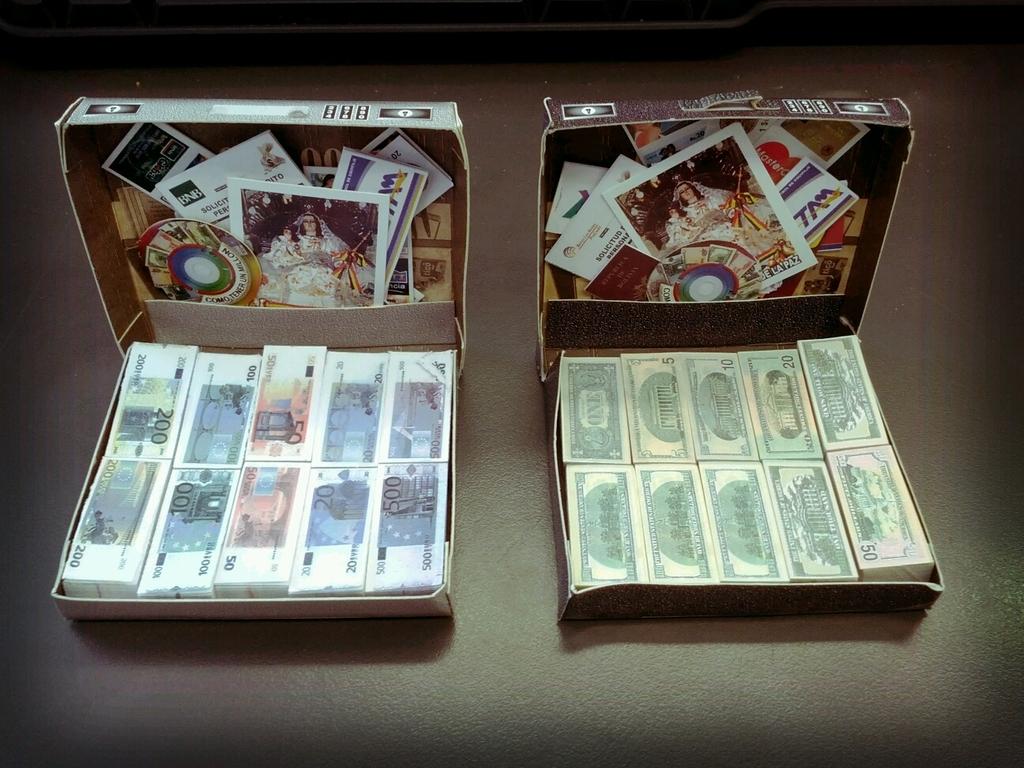What is the highest currency in the box on the left?
Ensure brevity in your answer.  500. 